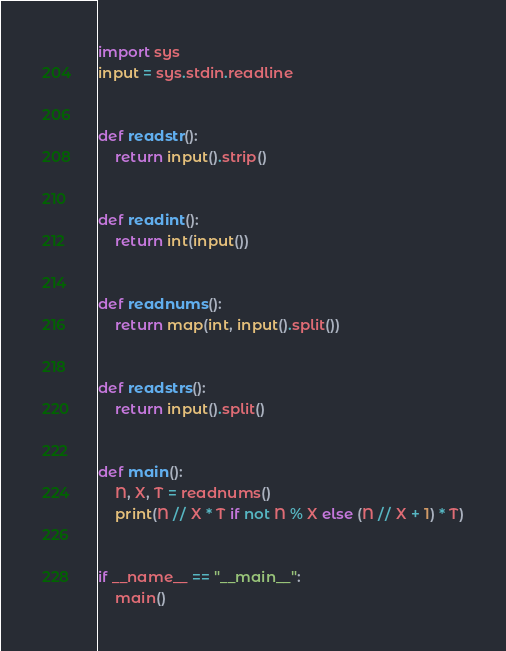Convert code to text. <code><loc_0><loc_0><loc_500><loc_500><_Python_>import sys
input = sys.stdin.readline


def readstr():
    return input().strip()


def readint():
    return int(input())


def readnums():
    return map(int, input().split())


def readstrs():
    return input().split()


def main():
    N, X, T = readnums()
    print(N // X * T if not N % X else (N // X + 1) * T)


if __name__ == "__main__":
    main()
</code> 